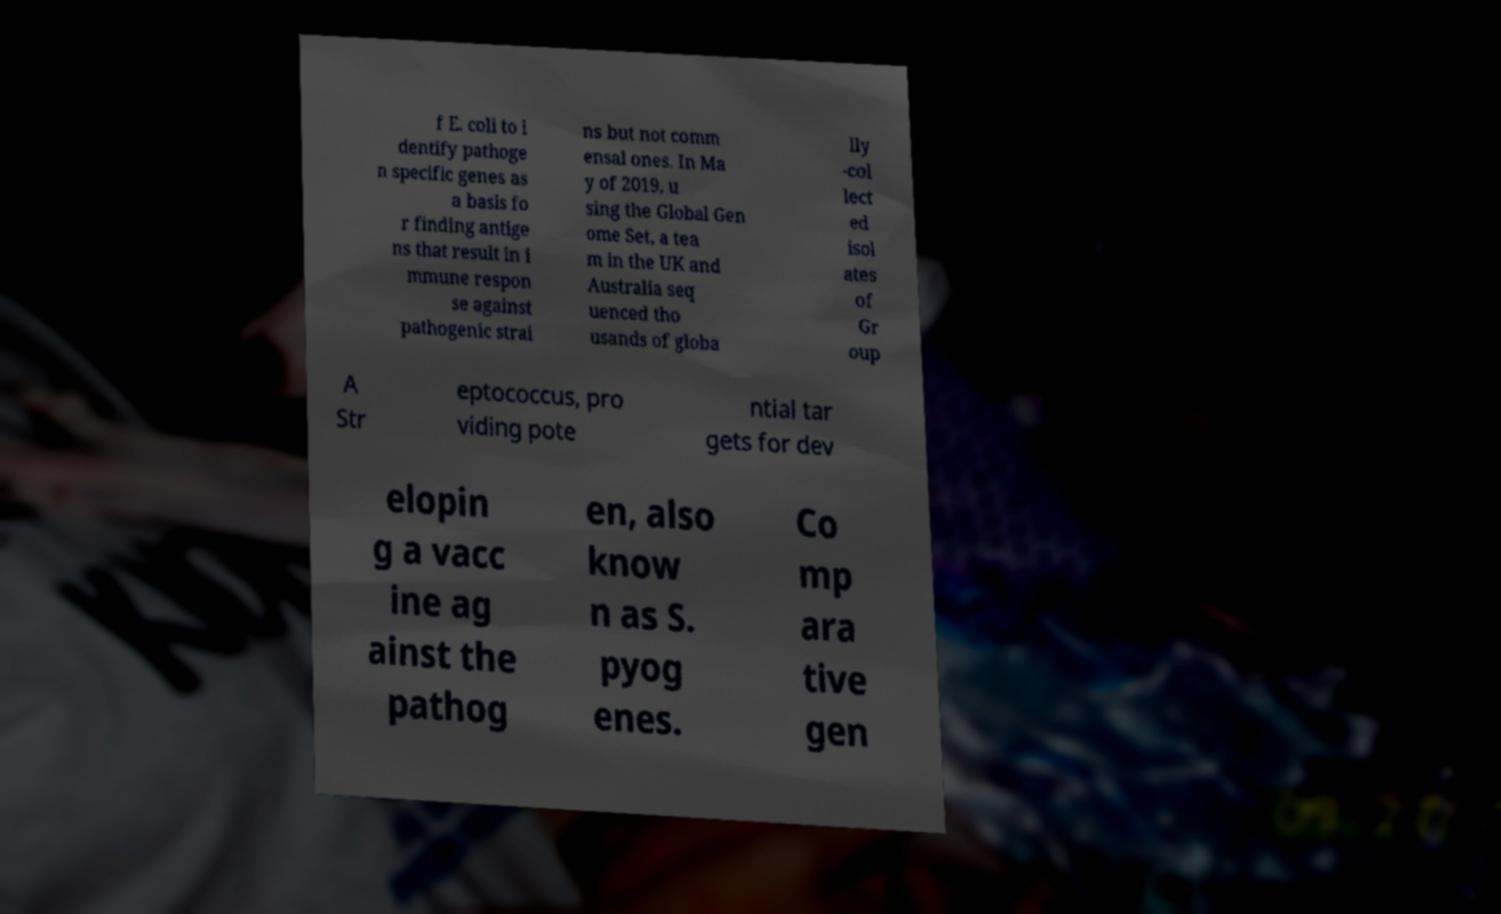Please identify and transcribe the text found in this image. f E. coli to i dentify pathoge n specific genes as a basis fo r finding antige ns that result in i mmune respon se against pathogenic strai ns but not comm ensal ones. In Ma y of 2019, u sing the Global Gen ome Set, a tea m in the UK and Australia seq uenced tho usands of globa lly -col lect ed isol ates of Gr oup A Str eptococcus, pro viding pote ntial tar gets for dev elopin g a vacc ine ag ainst the pathog en, also know n as S. pyog enes. Co mp ara tive gen 